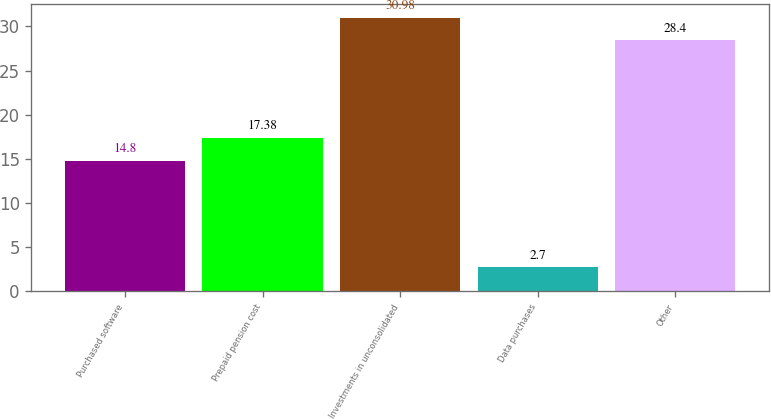<chart> <loc_0><loc_0><loc_500><loc_500><bar_chart><fcel>Purchased software<fcel>Prepaid pension cost<fcel>Investments in unconsolidated<fcel>Data purchases<fcel>Other<nl><fcel>14.8<fcel>17.38<fcel>30.98<fcel>2.7<fcel>28.4<nl></chart> 